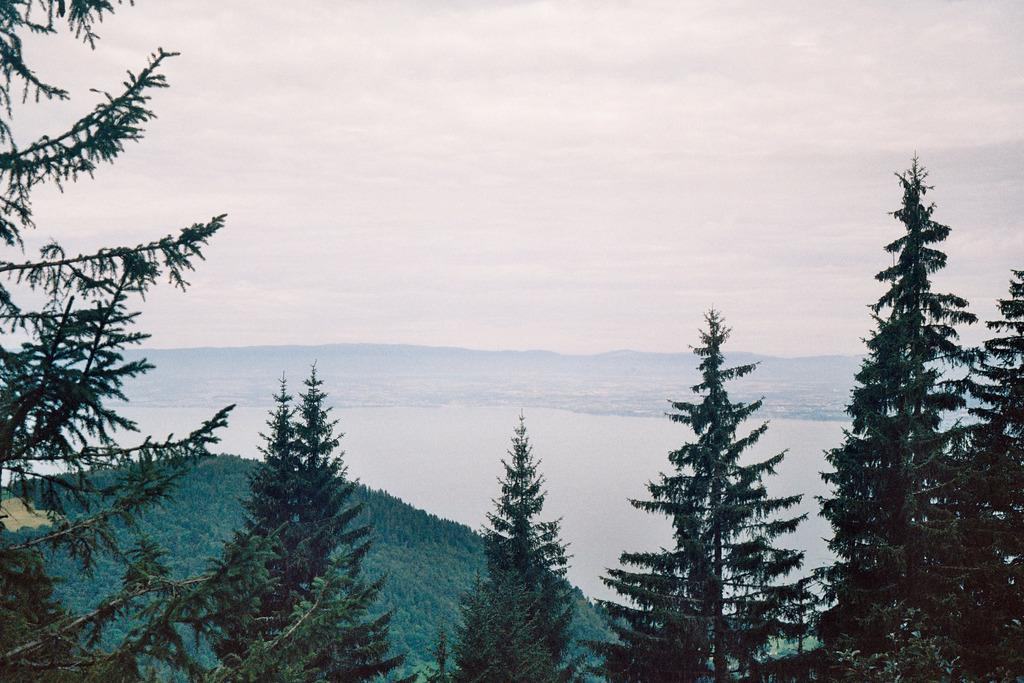What type of vegetation can be seen in the image? There are trees in the image. What natural features are visible in the background of the image? There are mountains and water visible in the background of the image. What else can be seen in the background of the image? The sky is visible in the background of the image. What type of payment is being made in the image? There is no payment being made in the image; it features trees, mountains, water, and the sky. Can you see any berries on the trees in the image? There is no mention of berries on the trees in the image; only trees are mentioned. 